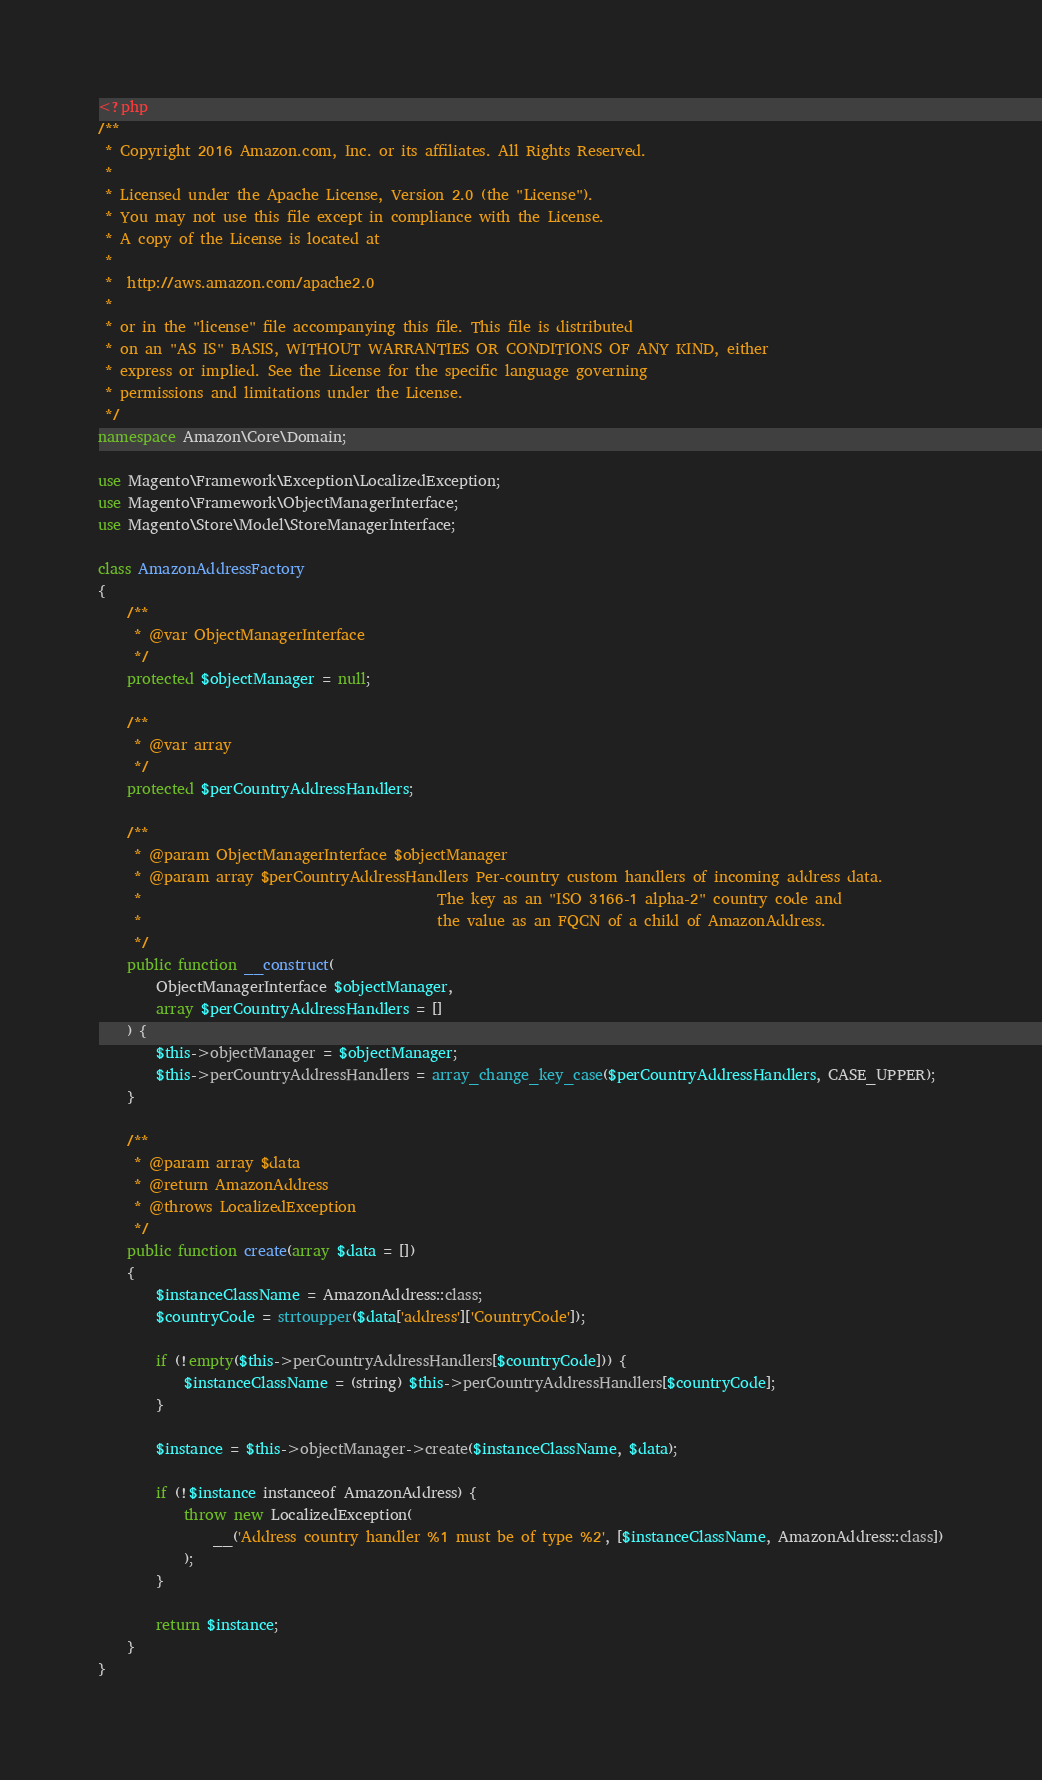Convert code to text. <code><loc_0><loc_0><loc_500><loc_500><_PHP_><?php
/**
 * Copyright 2016 Amazon.com, Inc. or its affiliates. All Rights Reserved.
 *
 * Licensed under the Apache License, Version 2.0 (the "License").
 * You may not use this file except in compliance with the License.
 * A copy of the License is located at
 *
 *  http://aws.amazon.com/apache2.0
 *
 * or in the "license" file accompanying this file. This file is distributed
 * on an "AS IS" BASIS, WITHOUT WARRANTIES OR CONDITIONS OF ANY KIND, either
 * express or implied. See the License for the specific language governing
 * permissions and limitations under the License.
 */
namespace Amazon\Core\Domain;

use Magento\Framework\Exception\LocalizedException;
use Magento\Framework\ObjectManagerInterface;
use Magento\Store\Model\StoreManagerInterface;

class AmazonAddressFactory
{
    /**
     * @var ObjectManagerInterface
     */
    protected $objectManager = null;

    /**
     * @var array
     */
    protected $perCountryAddressHandlers;

    /**
     * @param ObjectManagerInterface $objectManager
     * @param array $perCountryAddressHandlers Per-country custom handlers of incoming address data.
     *                                         The key as an "ISO 3166-1 alpha-2" country code and
     *                                         the value as an FQCN of a child of AmazonAddress.
     */
    public function __construct(
        ObjectManagerInterface $objectManager,
        array $perCountryAddressHandlers = []
    ) {
        $this->objectManager = $objectManager;
        $this->perCountryAddressHandlers = array_change_key_case($perCountryAddressHandlers, CASE_UPPER);
    }

    /**
     * @param array $data
     * @return AmazonAddress
     * @throws LocalizedException
     */
    public function create(array $data = [])
    {
        $instanceClassName = AmazonAddress::class;
        $countryCode = strtoupper($data['address']['CountryCode']);

        if (!empty($this->perCountryAddressHandlers[$countryCode])) {
            $instanceClassName = (string) $this->perCountryAddressHandlers[$countryCode];
        }

        $instance = $this->objectManager->create($instanceClassName, $data);

        if (!$instance instanceof AmazonAddress) {
            throw new LocalizedException(
                __('Address country handler %1 must be of type %2', [$instanceClassName, AmazonAddress::class])
            );
        }

        return $instance;
    }
}
</code> 